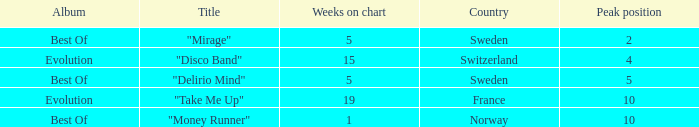What is the weeks on chart for the single from france? 19.0. 